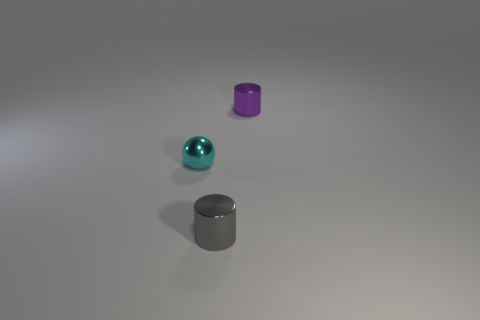Are there any other things that have the same shape as the gray thing?
Your answer should be very brief. Yes. The ball that is the same material as the purple thing is what color?
Ensure brevity in your answer.  Cyan. Are there any small metallic cylinders that are behind the small cylinder that is in front of the small cylinder that is right of the gray thing?
Provide a succinct answer. Yes. Is the number of gray cylinders that are to the right of the gray metallic cylinder less than the number of objects that are left of the tiny cyan shiny object?
Your answer should be very brief. No. What number of cyan things are the same material as the gray thing?
Keep it short and to the point. 1. Is the size of the cyan object the same as the purple shiny object behind the gray cylinder?
Keep it short and to the point. Yes. There is a object to the right of the cylinder that is left of the thing behind the small cyan metal thing; what is its size?
Offer a terse response. Small. Are there more tiny purple metallic cylinders on the left side of the tiny gray thing than gray shiny things that are left of the cyan shiny thing?
Your answer should be compact. No. There is a cylinder in front of the purple shiny object; what number of small things are behind it?
Provide a short and direct response. 2. Is there a object that has the same color as the sphere?
Offer a terse response. No. 